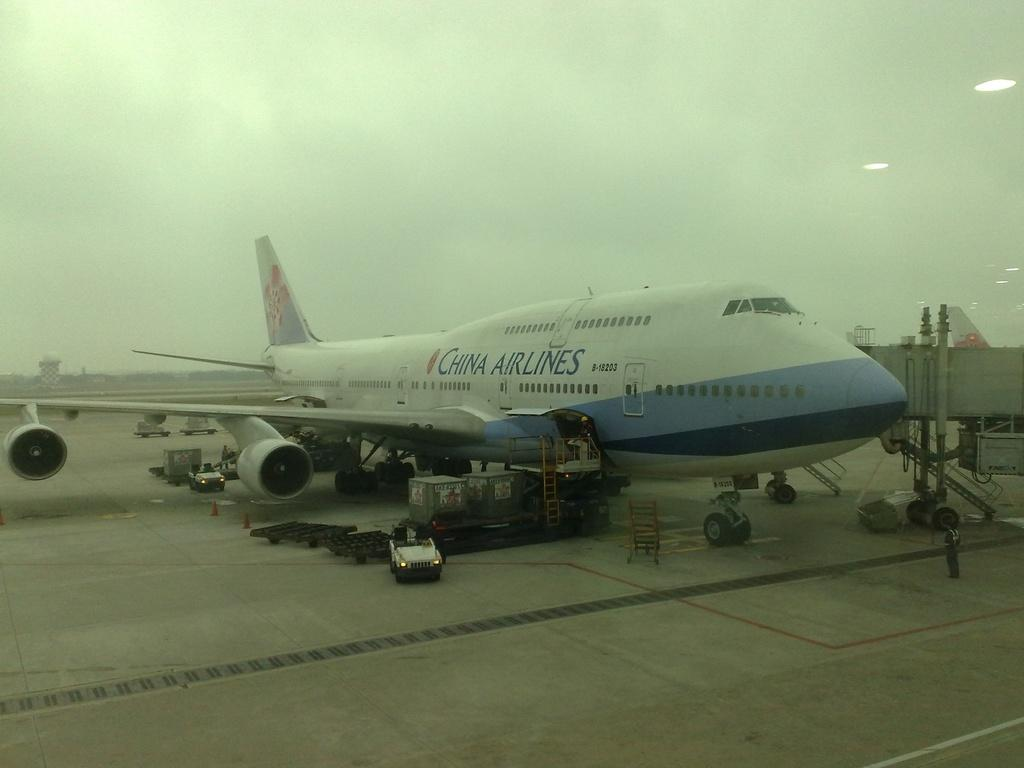<image>
Summarize the visual content of the image. The China Airlines aircraft has landed at the airport before the storm. 